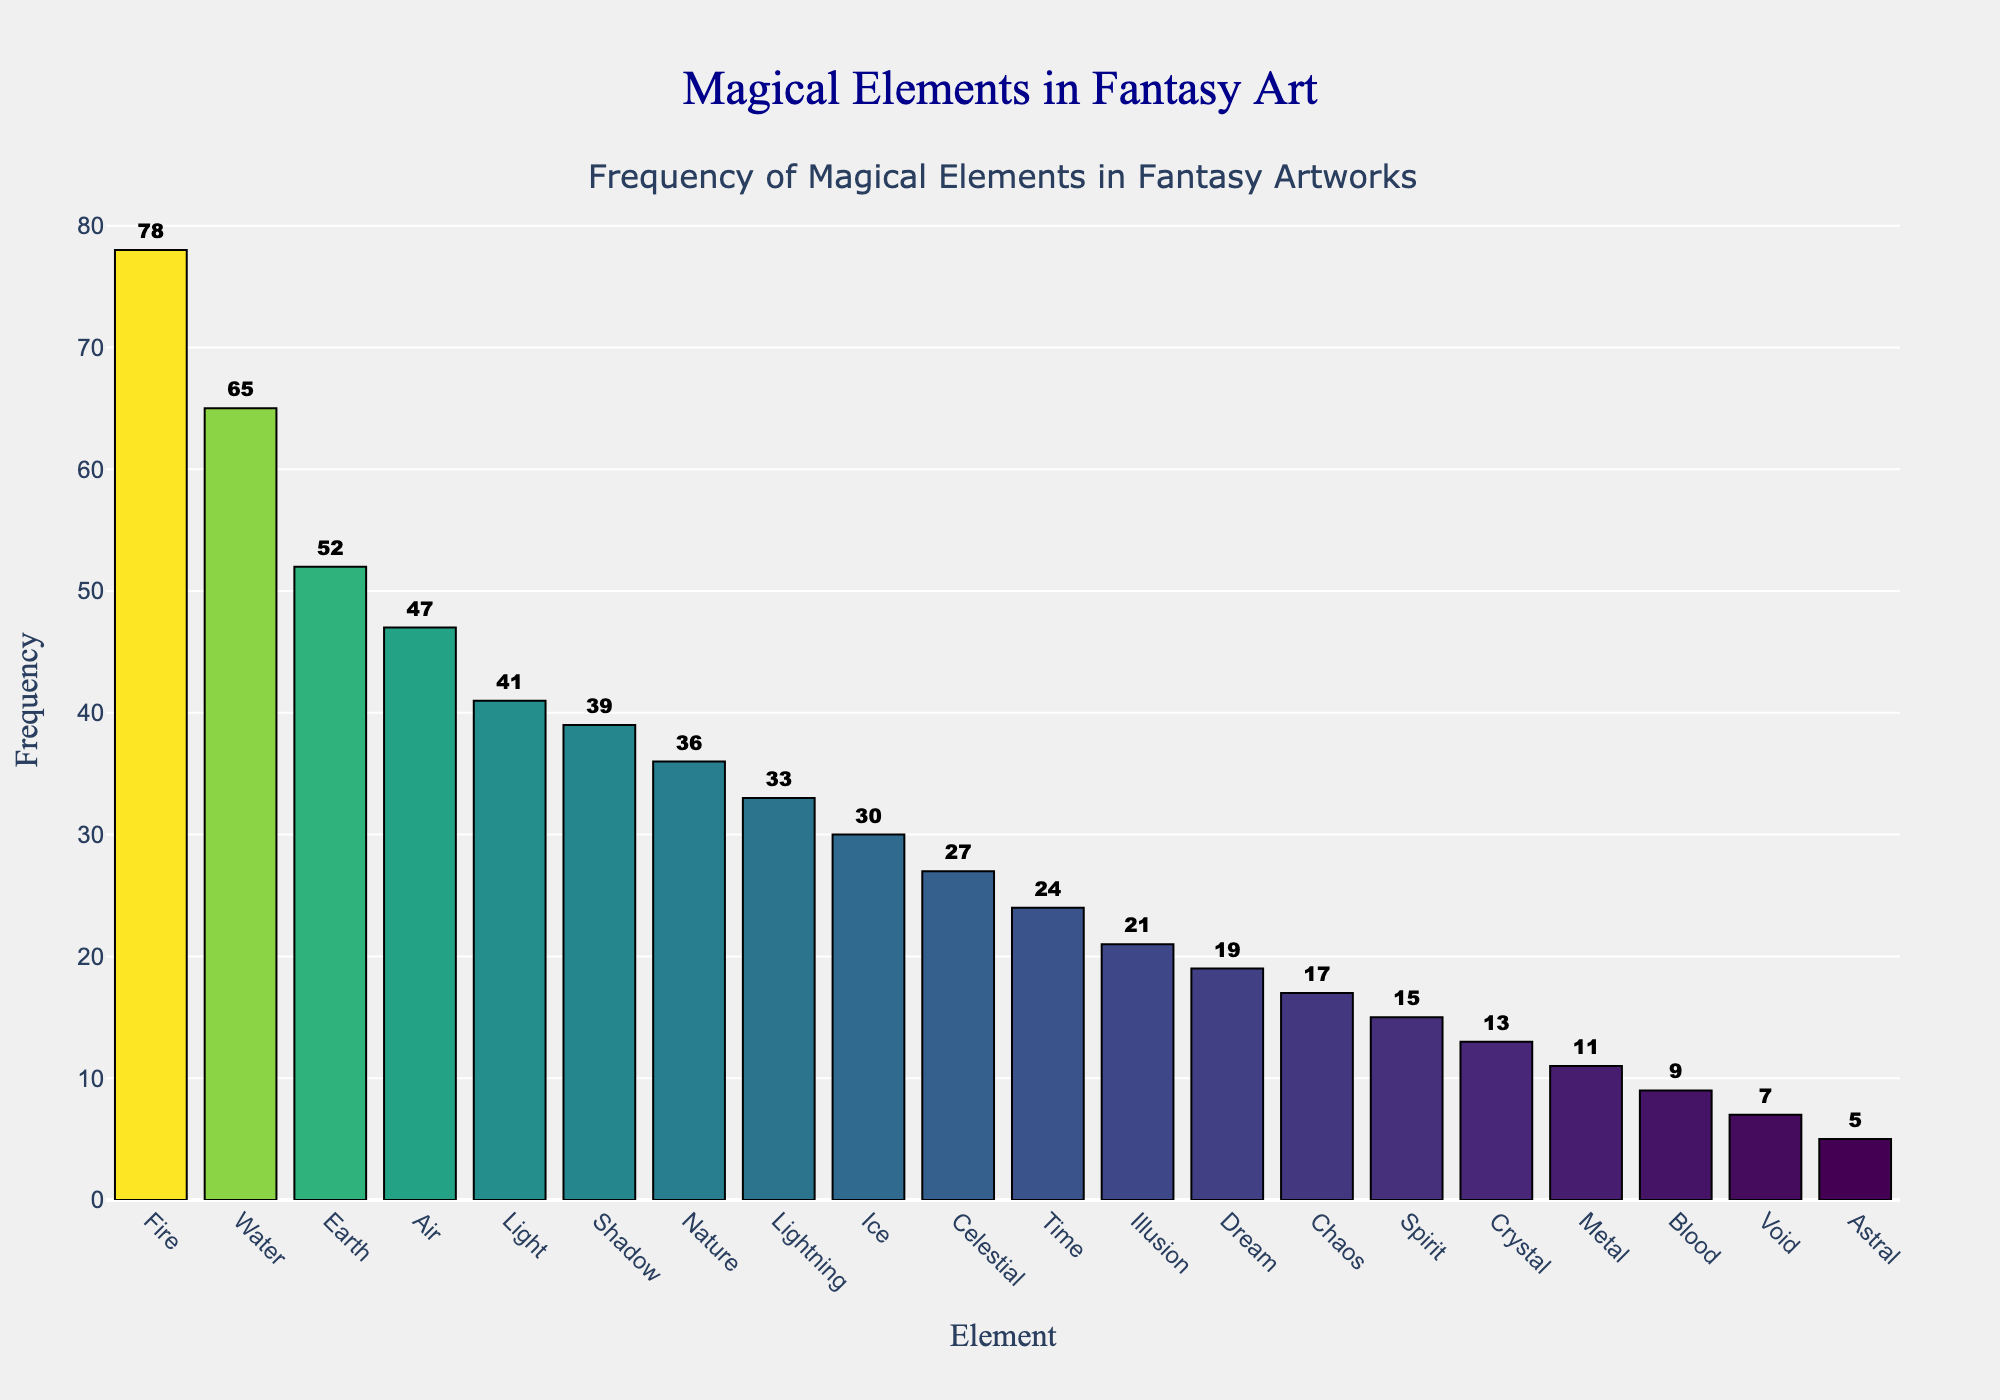what's the most frequent magical element in the fantasy artworks? By observing the height of the bars, the bar representing 'Fire' is the highest, indicating it has the highest frequency.
Answer: Fire Which element has a higher frequency: Nature or Shadow? By comparing the heights of the bars for ‘Nature’ and ‘Shadow’, ‘Shadow’ has a slightly higher bar, indicating a higher frequency.
Answer: Shadow What is the sum of the frequencies of Light, Air, and Earth? Locate the bars for ‘Light’, ‘Air’, and ‘Earth’ and add their frequencies: 41 (Light) + 47 (Air) + 52 (Earth) = 140.
Answer: 140 Which element has a frequency closest to 30? Identify the element whose bar height matches a frequency closest to 30. The ‘Ice’ element matches this frequency.
Answer: Ice How many elements have a frequency higher than 40? Count the number of bars that are higher than the 40-mark on the y-axis. The elements are Fire, Water, Earth, Air, and Light, so there are 5 elements.
Answer: 5 Is Lightning more frequent than Illusion? Compare the heights of the Lightning and Illusion bars. The Lightning bar is higher (33) than the Illusion bar (21).
Answer: Yes What is the average frequency of the elements Water, Earth, and Fire? Add the frequencies together: 65 (Water) + 52 (Earth) + 78 (Fire) = 195. Divide by the number of elements (3) to find the average: 195 / 3 = 65.
Answer: 65 Which element has the lowest frequency? Identify the element with the shortest bar. ‘Astral’ has the lowest frequency.
Answer: Astral How much more frequent is Fire compared to Chaos? Find the difference between Fire and Chaos frequencies: 78 (Fire) - 17 (Chaos) = 61.
Answer: 61 Arrange the elements Lightning, Ice, and Metal in descending order of frequency. Compare the heights of the Lightning, Ice, and Metal bars to determine the frequency: Lightning (33), Ice (30), Metal (11). Arrange in descending order: Lightning, Ice, Metal.
Answer: Lightning, Ice, Metal 